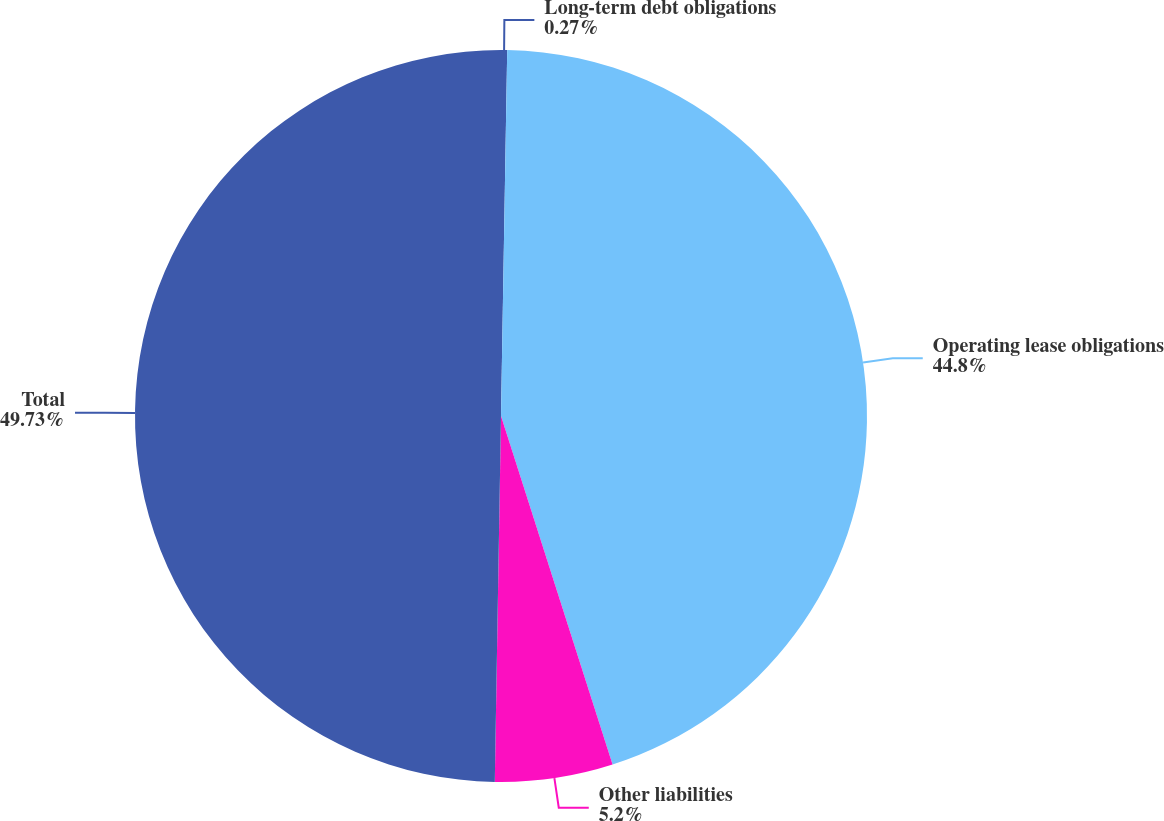<chart> <loc_0><loc_0><loc_500><loc_500><pie_chart><fcel>Long-term debt obligations<fcel>Operating lease obligations<fcel>Other liabilities<fcel>Total<nl><fcel>0.27%<fcel>44.8%<fcel>5.2%<fcel>49.73%<nl></chart> 